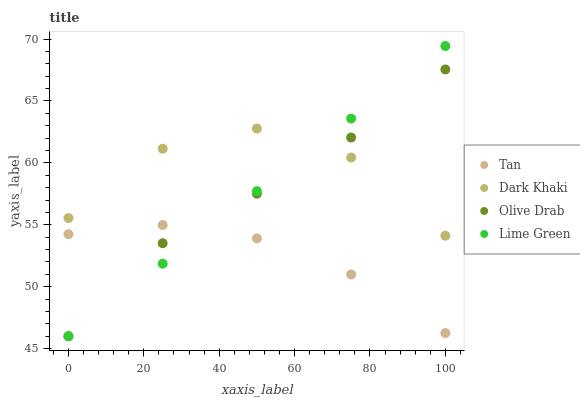Does Tan have the minimum area under the curve?
Answer yes or no. Yes. Does Dark Khaki have the maximum area under the curve?
Answer yes or no. Yes. Does Lime Green have the minimum area under the curve?
Answer yes or no. No. Does Lime Green have the maximum area under the curve?
Answer yes or no. No. Is Lime Green the smoothest?
Answer yes or no. Yes. Is Dark Khaki the roughest?
Answer yes or no. Yes. Is Tan the smoothest?
Answer yes or no. No. Is Tan the roughest?
Answer yes or no. No. Does Lime Green have the lowest value?
Answer yes or no. Yes. Does Tan have the lowest value?
Answer yes or no. No. Does Lime Green have the highest value?
Answer yes or no. Yes. Does Tan have the highest value?
Answer yes or no. No. Is Tan less than Dark Khaki?
Answer yes or no. Yes. Is Dark Khaki greater than Tan?
Answer yes or no. Yes. Does Dark Khaki intersect Lime Green?
Answer yes or no. Yes. Is Dark Khaki less than Lime Green?
Answer yes or no. No. Is Dark Khaki greater than Lime Green?
Answer yes or no. No. Does Tan intersect Dark Khaki?
Answer yes or no. No. 